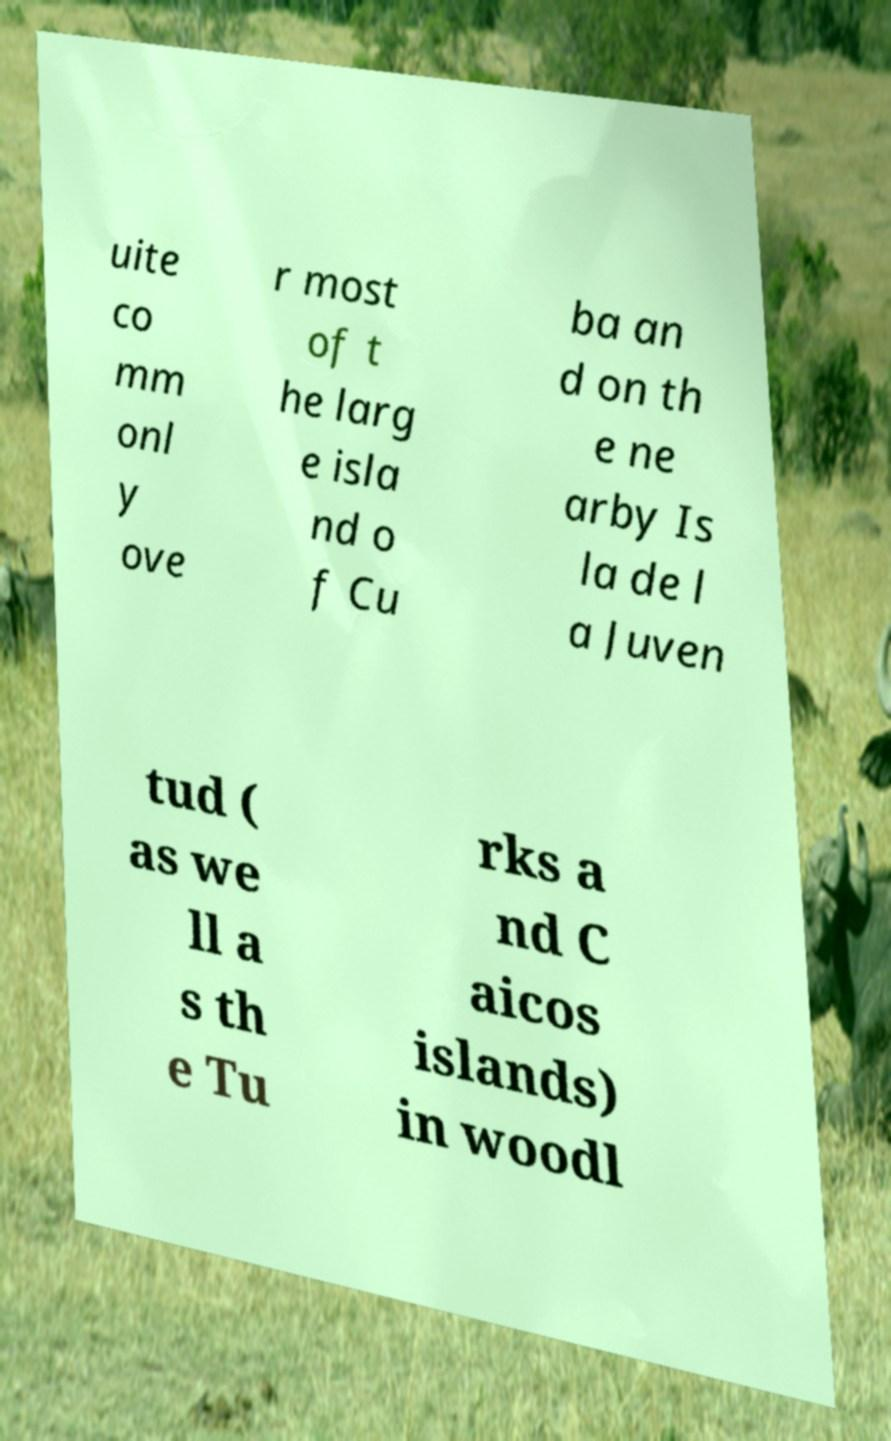Could you extract and type out the text from this image? uite co mm onl y ove r most of t he larg e isla nd o f Cu ba an d on th e ne arby Is la de l a Juven tud ( as we ll a s th e Tu rks a nd C aicos islands) in woodl 